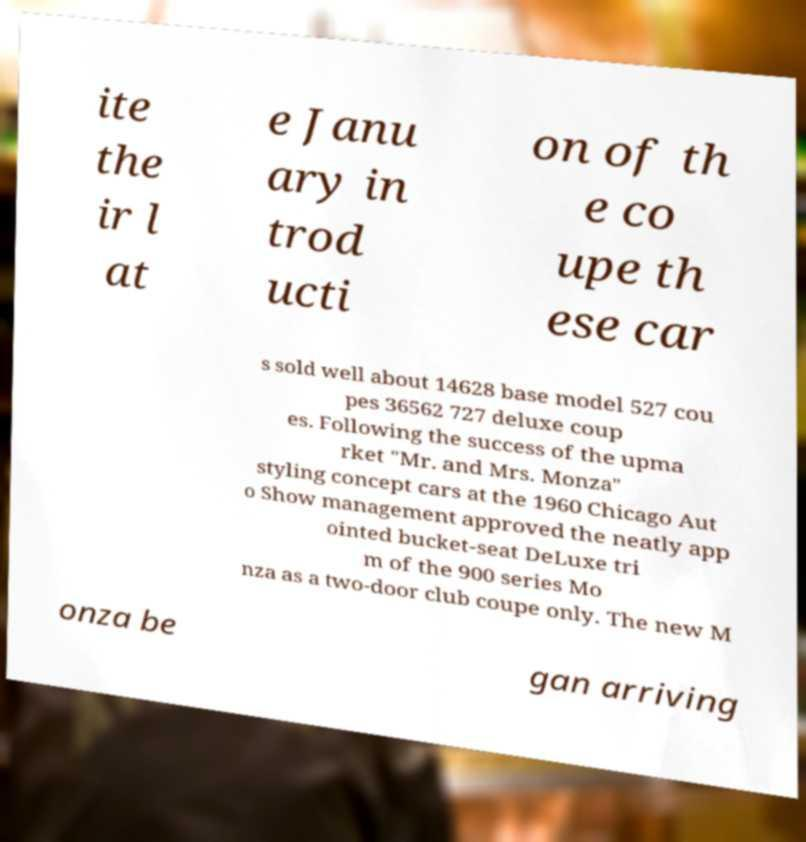Please identify and transcribe the text found in this image. ite the ir l at e Janu ary in trod ucti on of th e co upe th ese car s sold well about 14628 base model 527 cou pes 36562 727 deluxe coup es. Following the success of the upma rket "Mr. and Mrs. Monza" styling concept cars at the 1960 Chicago Aut o Show management approved the neatly app ointed bucket-seat DeLuxe tri m of the 900 series Mo nza as a two-door club coupe only. The new M onza be gan arriving 